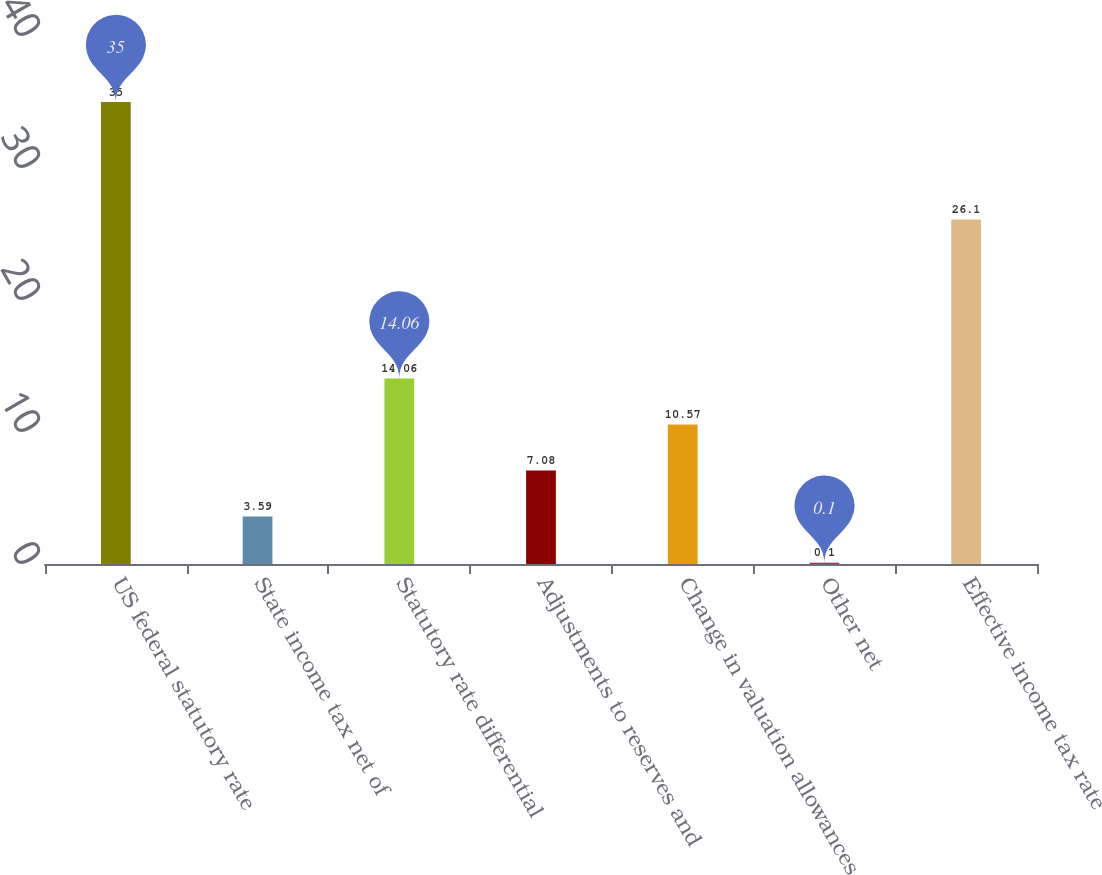Convert chart. <chart><loc_0><loc_0><loc_500><loc_500><bar_chart><fcel>US federal statutory rate<fcel>State income tax net of<fcel>Statutory rate differential<fcel>Adjustments to reserves and<fcel>Change in valuation allowances<fcel>Other net<fcel>Effective income tax rate<nl><fcel>35<fcel>3.59<fcel>14.06<fcel>7.08<fcel>10.57<fcel>0.1<fcel>26.1<nl></chart> 